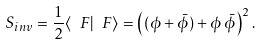<formula> <loc_0><loc_0><loc_500><loc_500>S _ { i n v } = \frac { 1 } { 2 } \langle \ F | \ F \rangle = \left ( ( \phi + \bar { \phi } ) + \phi \, \bar { \phi } \right ) ^ { 2 } .</formula> 